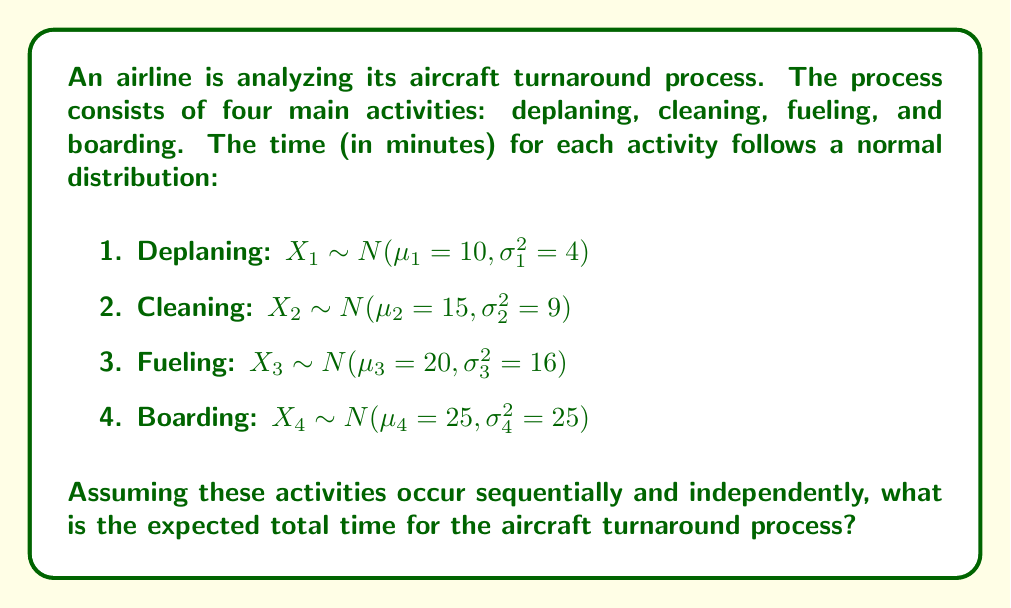Give your solution to this math problem. To solve this problem, we need to follow these steps:

1. Recall that for independent random variables, the expected value of their sum is equal to the sum of their individual expected values:

   $E(X_1 + X_2 + X_3 + X_4) = E(X_1) + E(X_2) + E(X_3) + E(X_4)$

2. For a normal distribution $N(\mu, \sigma^2)$, the expected value is equal to $\mu$. Therefore:

   $E(X_1) = \mu_1 = 10$
   $E(X_2) = \mu_2 = 15$
   $E(X_3) = \mu_3 = 20$
   $E(X_4) = \mu_4 = 25$

3. Sum up the expected values:

   $E(\text{Total Time}) = E(X_1) + E(X_2) + E(X_3) + E(X_4)$
   $E(\text{Total Time}) = 10 + 15 + 20 + 25$
   $E(\text{Total Time}) = 70$

Therefore, the expected total time for the aircraft turnaround process is 70 minutes.

Note: While we don't need the variances ($\sigma^2$) to calculate the expected value, they would be useful if we wanted to calculate the variance or standard deviation of the total time.
Answer: 70 minutes 